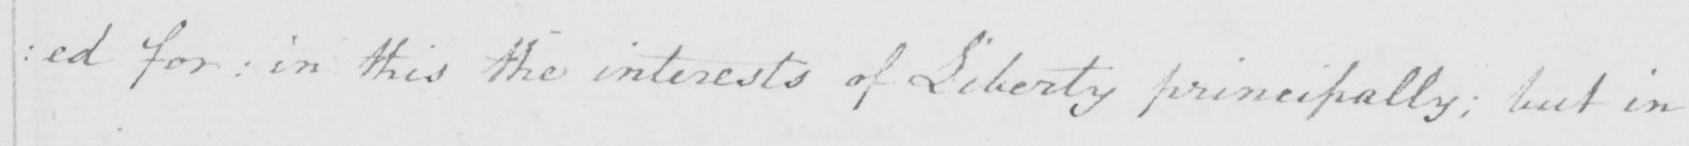Can you tell me what this handwritten text says? : ed for :  in this the interests of Liberty principally ; but in 